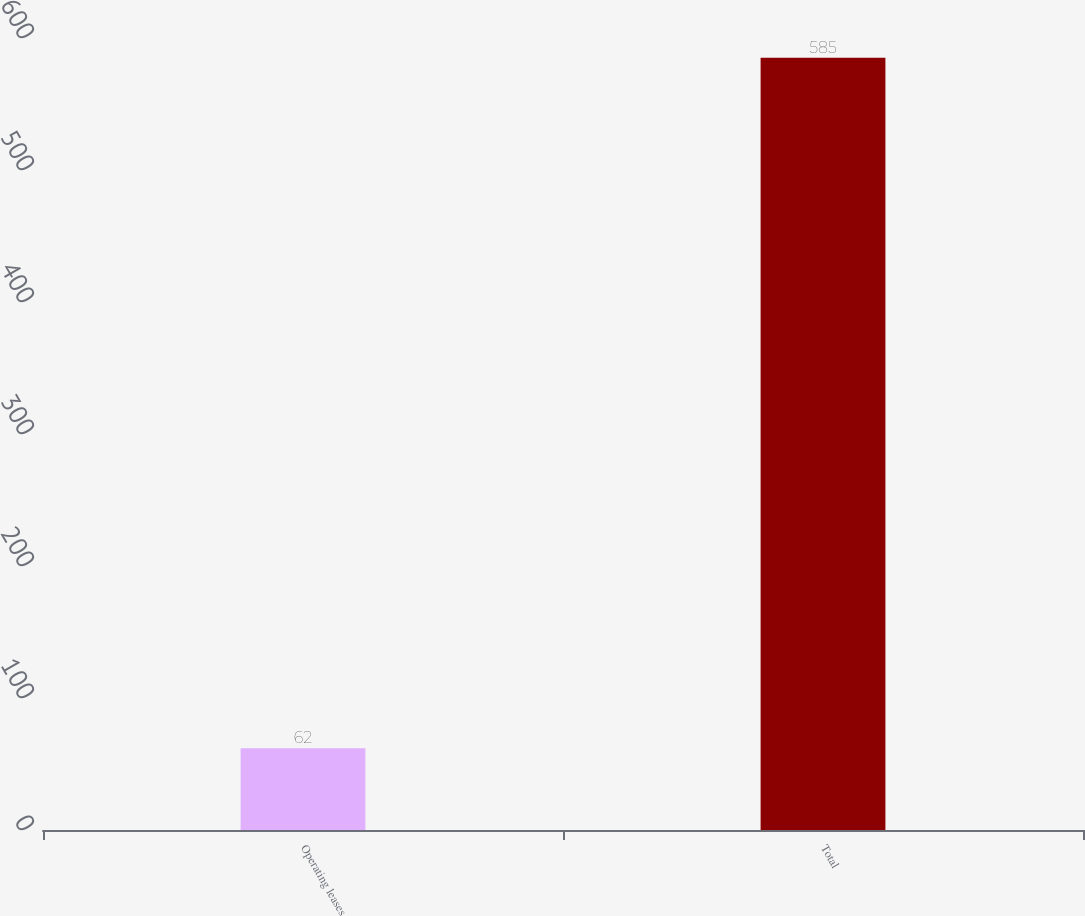Convert chart to OTSL. <chart><loc_0><loc_0><loc_500><loc_500><bar_chart><fcel>Operating leases<fcel>Total<nl><fcel>62<fcel>585<nl></chart> 